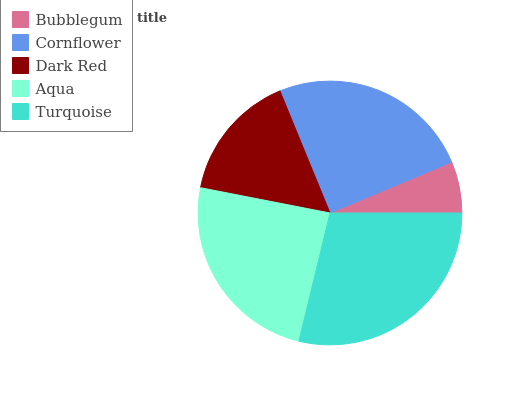Is Bubblegum the minimum?
Answer yes or no. Yes. Is Turquoise the maximum?
Answer yes or no. Yes. Is Cornflower the minimum?
Answer yes or no. No. Is Cornflower the maximum?
Answer yes or no. No. Is Cornflower greater than Bubblegum?
Answer yes or no. Yes. Is Bubblegum less than Cornflower?
Answer yes or no. Yes. Is Bubblegum greater than Cornflower?
Answer yes or no. No. Is Cornflower less than Bubblegum?
Answer yes or no. No. Is Aqua the high median?
Answer yes or no. Yes. Is Aqua the low median?
Answer yes or no. Yes. Is Dark Red the high median?
Answer yes or no. No. Is Dark Red the low median?
Answer yes or no. No. 